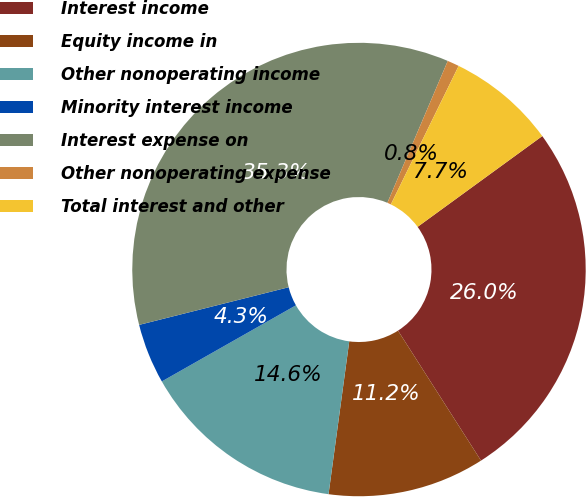Convert chart. <chart><loc_0><loc_0><loc_500><loc_500><pie_chart><fcel>Interest income<fcel>Equity income in<fcel>Other nonoperating income<fcel>Minority interest income<fcel>Interest expense on<fcel>Other nonoperating expense<fcel>Total interest and other<nl><fcel>25.97%<fcel>11.19%<fcel>14.64%<fcel>4.29%<fcel>35.33%<fcel>0.84%<fcel>7.74%<nl></chart> 